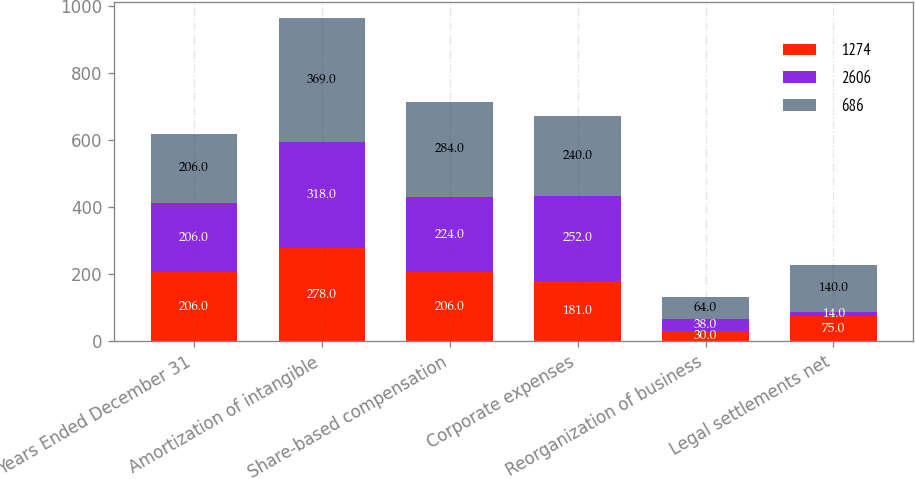Convert chart to OTSL. <chart><loc_0><loc_0><loc_500><loc_500><stacked_bar_chart><ecel><fcel>Years Ended December 31<fcel>Amortization of intangible<fcel>Share-based compensation<fcel>Corporate expenses<fcel>Reorganization of business<fcel>Legal settlements net<nl><fcel>1274<fcel>206<fcel>278<fcel>206<fcel>181<fcel>30<fcel>75<nl><fcel>2606<fcel>206<fcel>318<fcel>224<fcel>252<fcel>38<fcel>14<nl><fcel>686<fcel>206<fcel>369<fcel>284<fcel>240<fcel>64<fcel>140<nl></chart> 